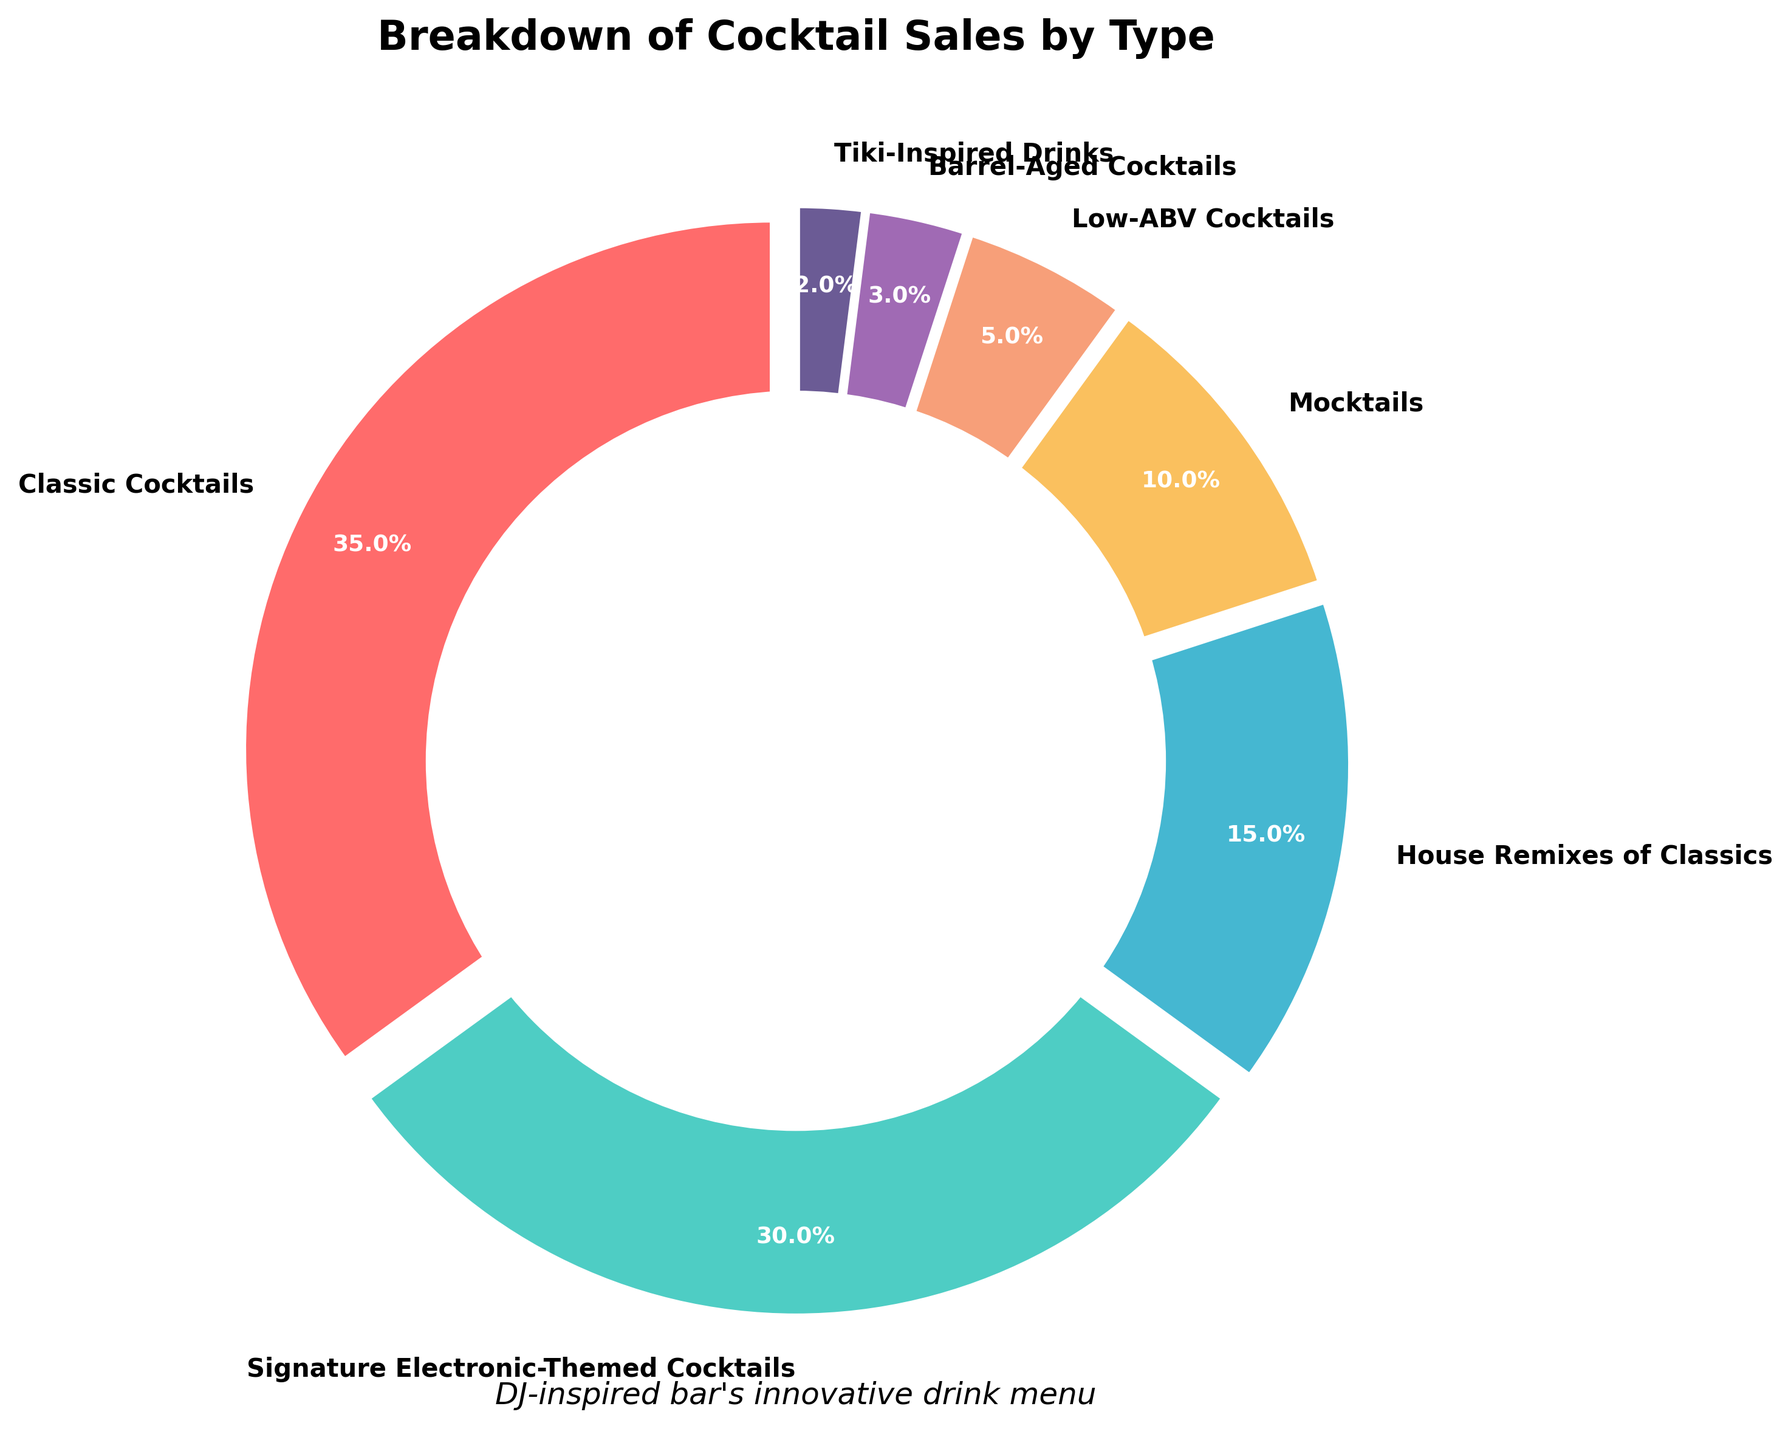What percentage of the total cocktail sales do the High-ABV drinks (Classics, Signature Electronic-Themed Cocktails, House Remixes of Classics, Barrel-Aged Cocktails, and Tiki-Inspired Drinks) represent? To find the percentage of the total cocktail sales for the High-ABV drinks, we sum up the percentages of Classic Cocktails, Signature Electronic-Themed Cocktails, House Remixes of Classics, Barrel-Aged Cocktails, and Tiki-Inspired Drinks. The calculation is 35% + 30% + 15% + 3% + 2% = 85%.
Answer: 85% Which cocktail type has the smallest share of sales? By examining the data, the Tiki-Inspired Drinks have the smallest share at 2% of total sales.
Answer: Tiki-Inspired Drinks Among the non-alcoholic drinks (Mocktails, Low-ABV Cocktails), which has a higher percentage of sales? Comparing Mocktails and Low-ABV Cocktails, Mocktails have a higher percentage of sales with 10%, while Low-ABV Cocktails have 5%.
Answer: Mocktails What is the total percentage of sales contributed by the House Remixes of Classics and Barrel-Aged Cocktails combined? Summing up the percentages of sales from House Remixes of Classics (15%) and Barrel-Aged Cocktails (3%), the total is 15% + 3% = 18%.
Answer: 18% Do Classic Cocktails and Signature Electronic-Themed Cocktails together account for more than 60% of the total sales? Adding the percentages of Classic Cocktails (35%) and Signature Electronic-Themed Cocktails (30%), the total is 35% + 30% = 65%. Since 65% is greater than 60%, the answer is yes.
Answer: Yes How much more popular are Signature Electronic-Themed Cocktails compared to Tiki-Inspired Drinks? To determine how much more popular Signature Electronic-Themed Cocktails are compared to Tiki-Inspired Drinks, we subtract the percentage of Tiki-Inspired Drinks (2%) from Signature Electronic-Themed Cocktails (30%). The difference is 30% - 2% = 28%.
Answer: 28% Compare the sales share of Signature Electronic-Themed Cocktails to Low-ABV Cocktails. Which one is higher and by how much? Signature Electronic-Themed Cocktails have a sales share of 30%, while Low-ABV Cocktails have 5%. The Signature Electronic-Themed Cocktails are higher by 30% - 5% = 25%.
Answer: Signature Electronic-Themed Cocktails, 25% Which cocktail type accounts for one-third of the sales percentage of Classic Cocktails? To find one-third of the Classic Cocktails' sales percentage, we divide 35% by 3, which equals approximately 11.67%. None of the categories exactly correspond to this percentage, but Mocktails are closest with 10%.
Answer: Mocktails What colors are used to represent the Low-ABV Cocktails and Barrel-Aged Cocktails in the pie chart? In the pie chart, the Low-ABV Cocktails are represented by the color purple, and the Barrel-Aged Cocktails are represented by the color violet.
Answer: Purple and Violet 